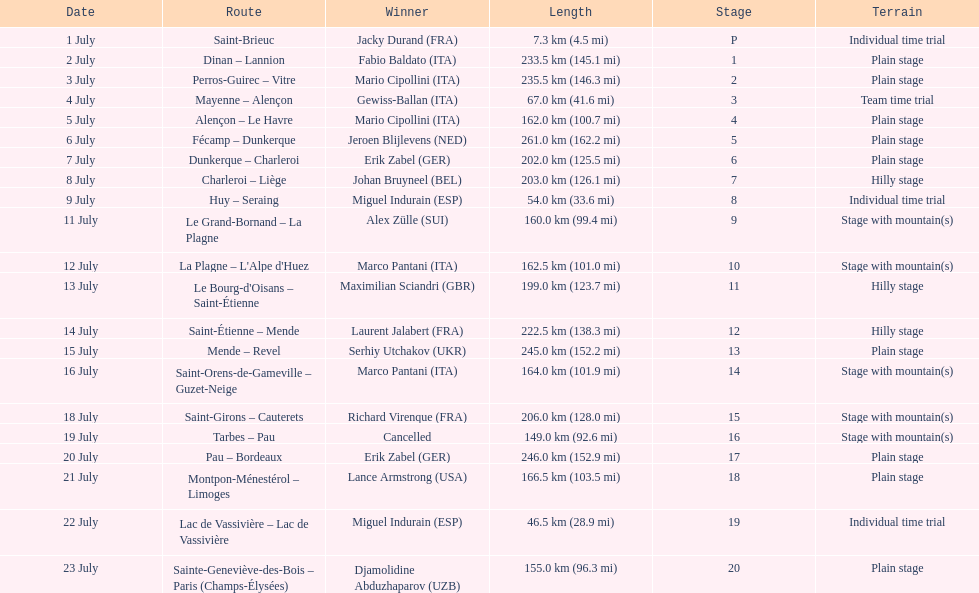Which country had more stage-winners than any other country? Italy. 